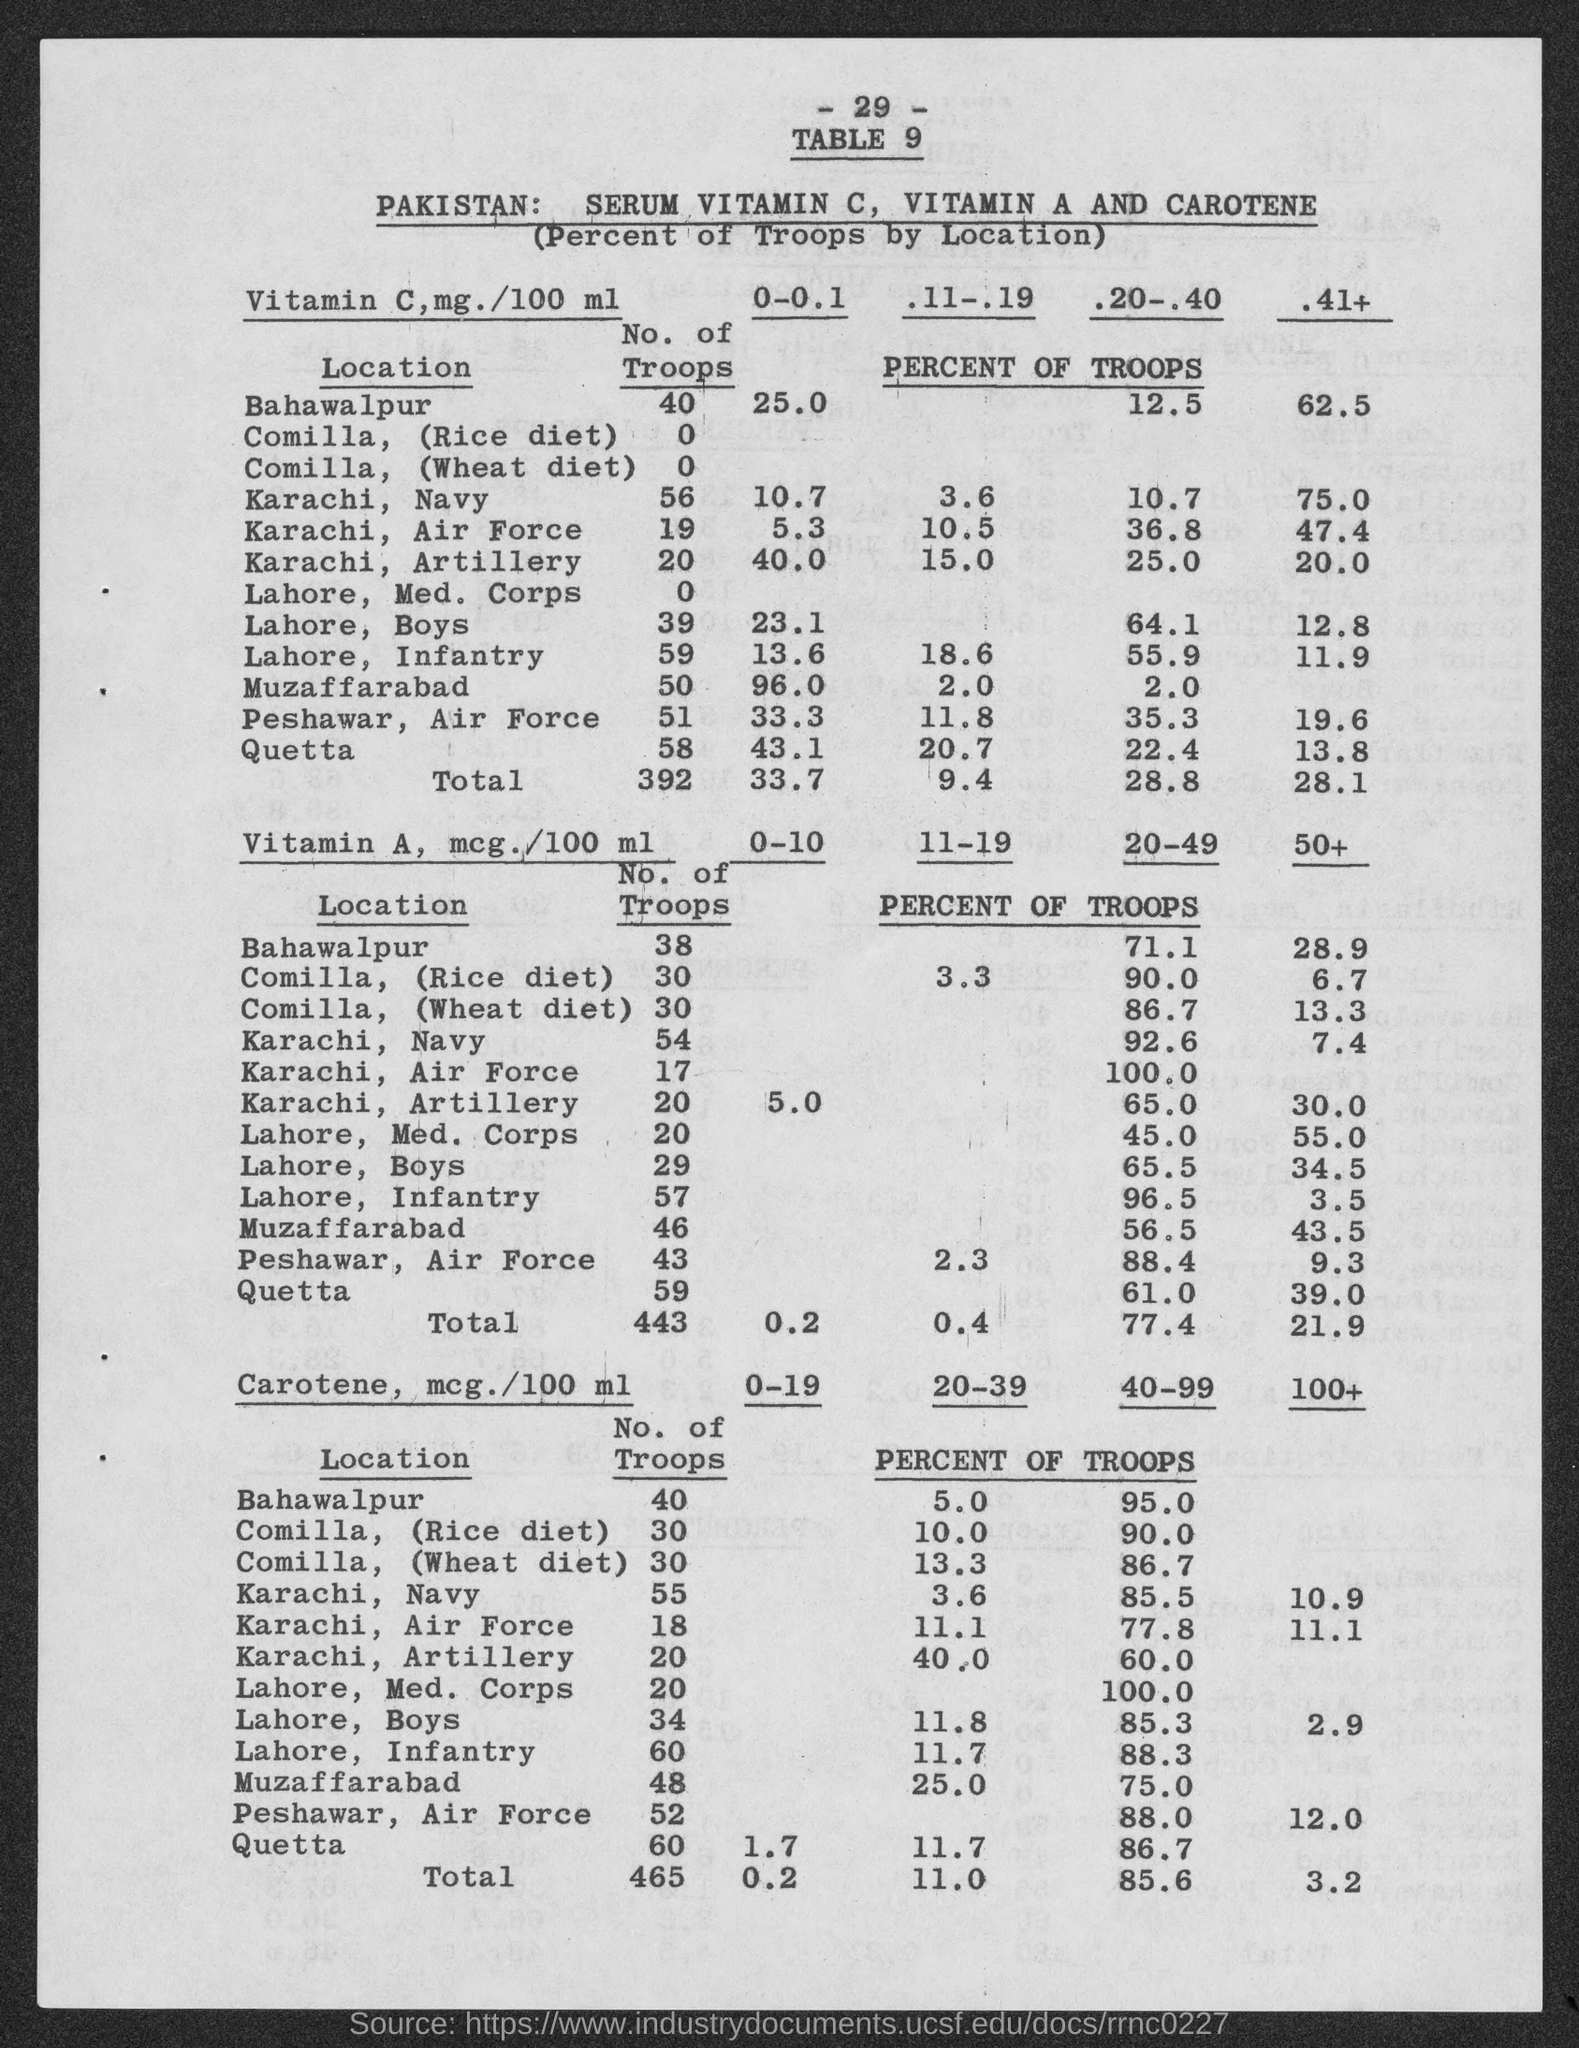Mention a couple of crucial points in this snapshot. The number of troops under Vitamin C in Lahore is 39. The number at the top of the page is 29. The number of troops under Vitamin C in Karachi, Air Force is 19. There are 56 troops under Vitamin C in the Navy stationed in Karachi. There are zero troops under Vitamin C in Lahore, Medical Corps. 